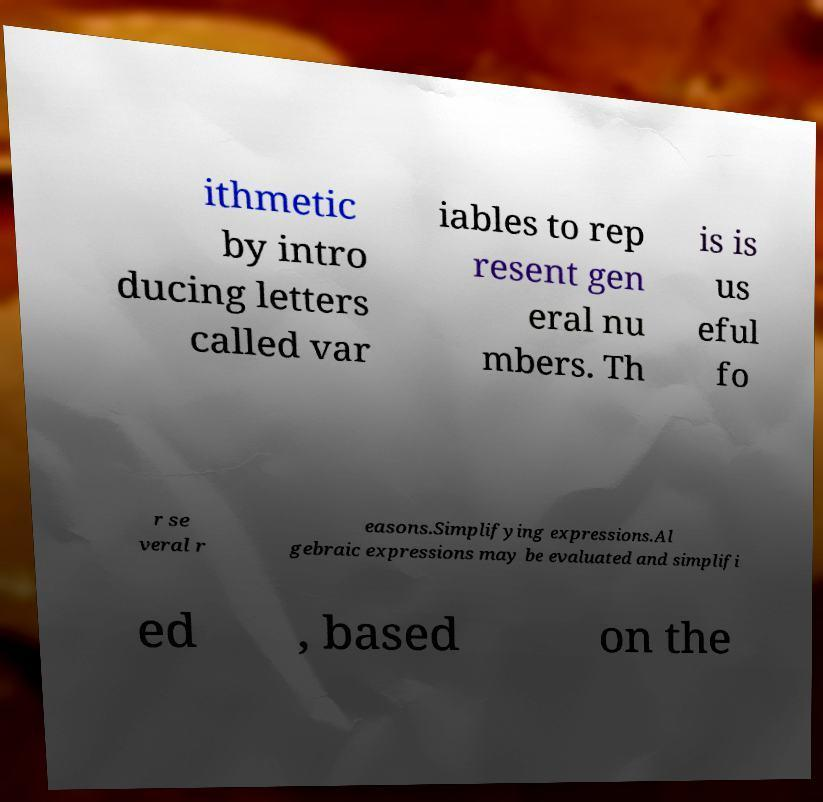Please identify and transcribe the text found in this image. ithmetic by intro ducing letters called var iables to rep resent gen eral nu mbers. Th is is us eful fo r se veral r easons.Simplifying expressions.Al gebraic expressions may be evaluated and simplifi ed , based on the 